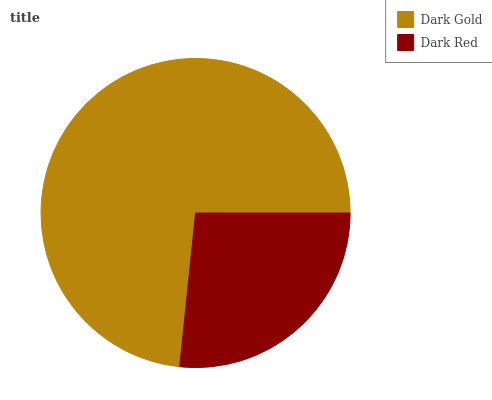Is Dark Red the minimum?
Answer yes or no. Yes. Is Dark Gold the maximum?
Answer yes or no. Yes. Is Dark Red the maximum?
Answer yes or no. No. Is Dark Gold greater than Dark Red?
Answer yes or no. Yes. Is Dark Red less than Dark Gold?
Answer yes or no. Yes. Is Dark Red greater than Dark Gold?
Answer yes or no. No. Is Dark Gold less than Dark Red?
Answer yes or no. No. Is Dark Gold the high median?
Answer yes or no. Yes. Is Dark Red the low median?
Answer yes or no. Yes. Is Dark Red the high median?
Answer yes or no. No. Is Dark Gold the low median?
Answer yes or no. No. 